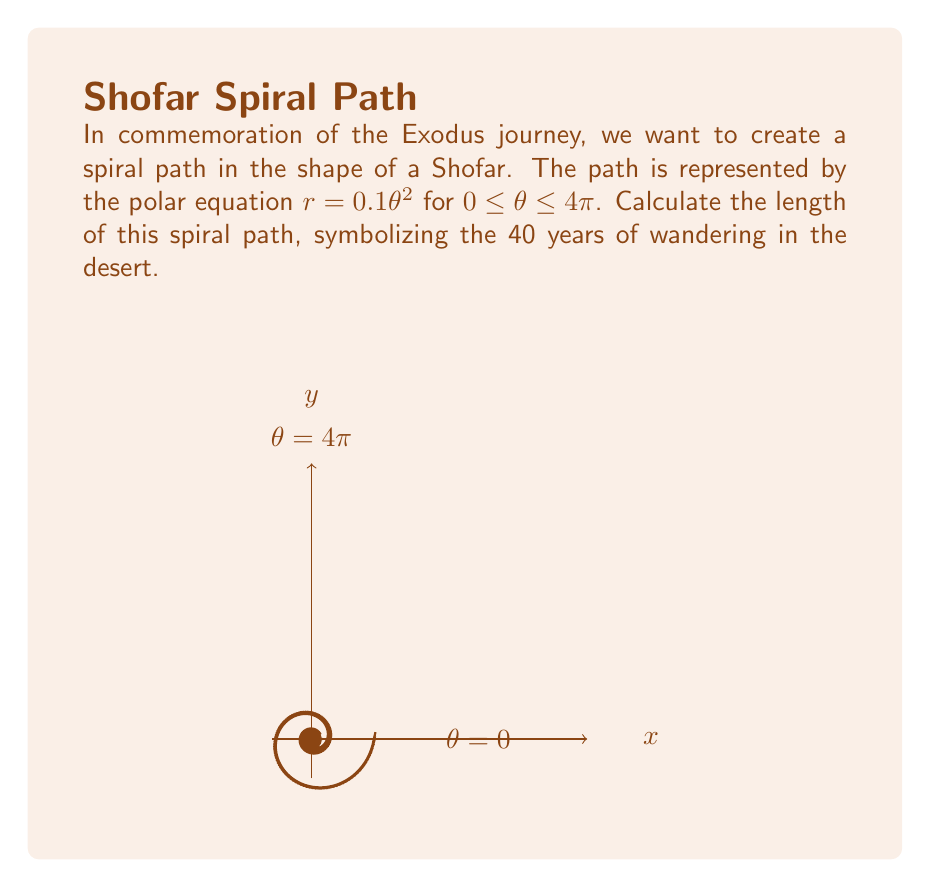Give your solution to this math problem. To find the length of the spiral path, we'll use the formula for arc length in polar coordinates:

$$L = \int_a^b \sqrt{r^2 + \left(\frac{dr}{d\theta}\right)^2} d\theta$$

Given: $r = 0.1\theta^2$, $0 \leq \theta \leq 4\pi$

Step 1: Find $\frac{dr}{d\theta}$
$$\frac{dr}{d\theta} = 0.2\theta$$

Step 2: Substitute into the arc length formula
$$L = \int_0^{4\pi} \sqrt{(0.1\theta^2)^2 + (0.2\theta)^2} d\theta$$

Step 3: Simplify under the square root
$$L = \int_0^{4\pi} \sqrt{0.01\theta^4 + 0.04\theta^2} d\theta$$
$$L = \int_0^{4\pi} 0.1\theta\sqrt{\theta^2 + 4} d\theta$$

Step 4: This integral is difficult to solve analytically. We can use the substitution $u = \theta^2 + 4$, but it still leads to a complex expression. Instead, we'll use numerical integration.

Step 5: Using a numerical integration method (e.g., Simpson's rule or a computer algebra system), we get:

$$L \approx 161.02$$

This value represents the length of the spiral path in the same units as the radial distance.
Answer: $161.02$ units 